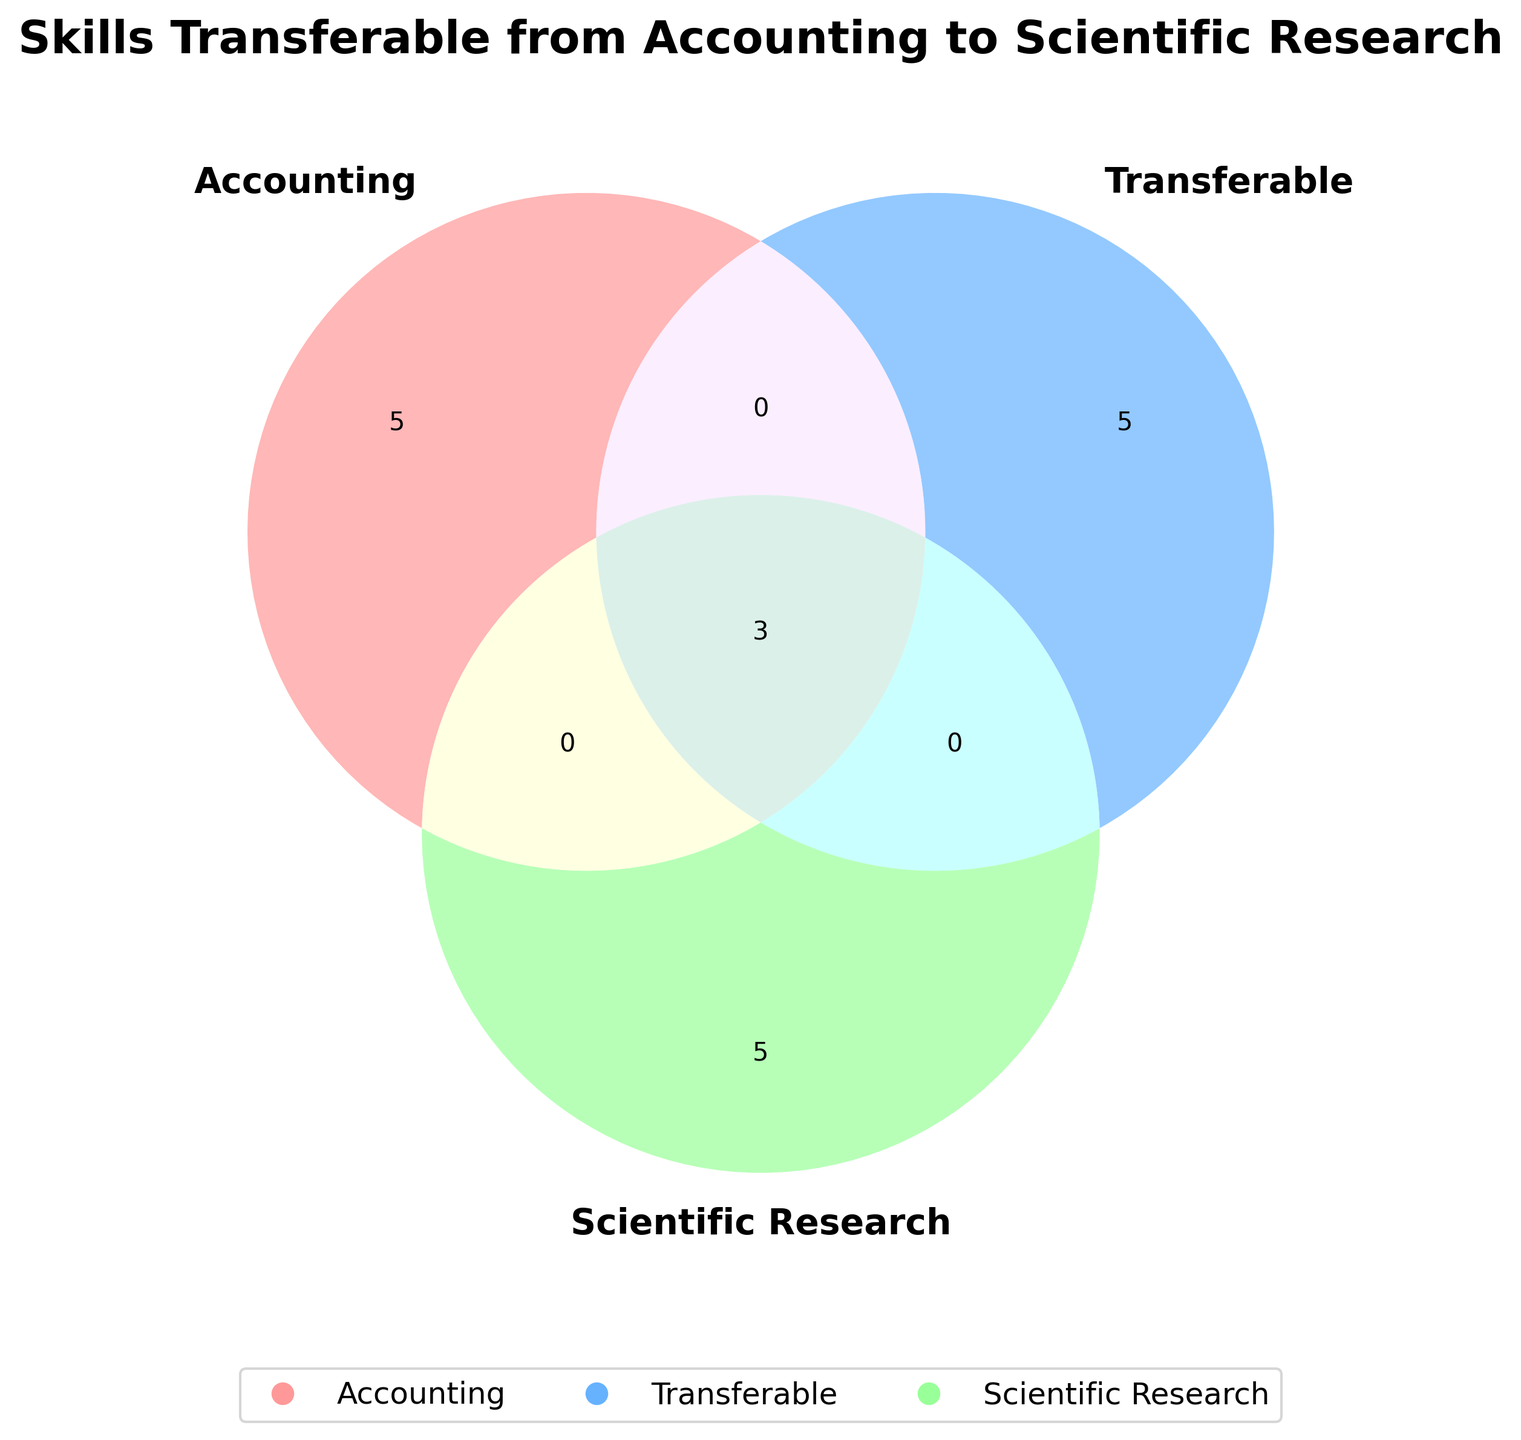What's the title of the figure? The title is usually found at the top of the figure. Here, it is clearly written in bold.
Answer: Skills Transferable from Accounting to Scientific Research Which skills are common to all three areas: Accounting, Transferable, and Scientific Research? Look at the central section where all three circles intersect; these skills are common to all areas.
Answer: Analytical thinking, Data management, Attention to detail What is the most specific skill listed for Scientific Research that isn't common with Accounting? Locate the section for Scientific Research that doesn't intersect with the Accounting circle.
Answer: Hypothesis testing How many skills are listed only under Accounting but not transferable? Look solely within the Accounting circle that does not intersect with Transferable circle.
Answer: Three skills (Financial reporting, Auditing, Budgeting, Tax planning, Regulatory compliance) Is 'Statistical analysis' a skill more aligned with scientific research or accounting? Check which part of the diagram includes 'Statistical analysis' and how it aligns with other sections.
Answer: Scientific Research Which skill appears both in Transferable and Scientific Research but not in Accounting? Identify any skills in the overlapping part of Transferable and Scientific Research circles, excluding Accounting.
Answer: Problem-solving, Statistical analysis What skills fall under the category of Scientific Research but are not transferable? Identify skills situated in the Scientific Research circle that do not overlap with the Transferable circle.
Answer: Hypothesis testing, Experimental design, Peer review process Which skill is both a transferable skill and used in Hypothesis Testing but not listed under Accounting skills? Locate skills that overlap between Transferable and Scientific Research but not in Accounting.
Answer: Critical thinking Do 'Peer review process' and 'Report writing' belong to any common overlapping sets? Look at where these skills are placed in the diagram and see if they share an intersecting section.
Answer: No, they do not belong to a common overlapping set Which skills are only transferable but not specific to Accounting or Scientific Research? Identify the skills located solely in the Transferable Skills circle without intersections.
Answer: Report writing, Critical thinking, Problem-solving 